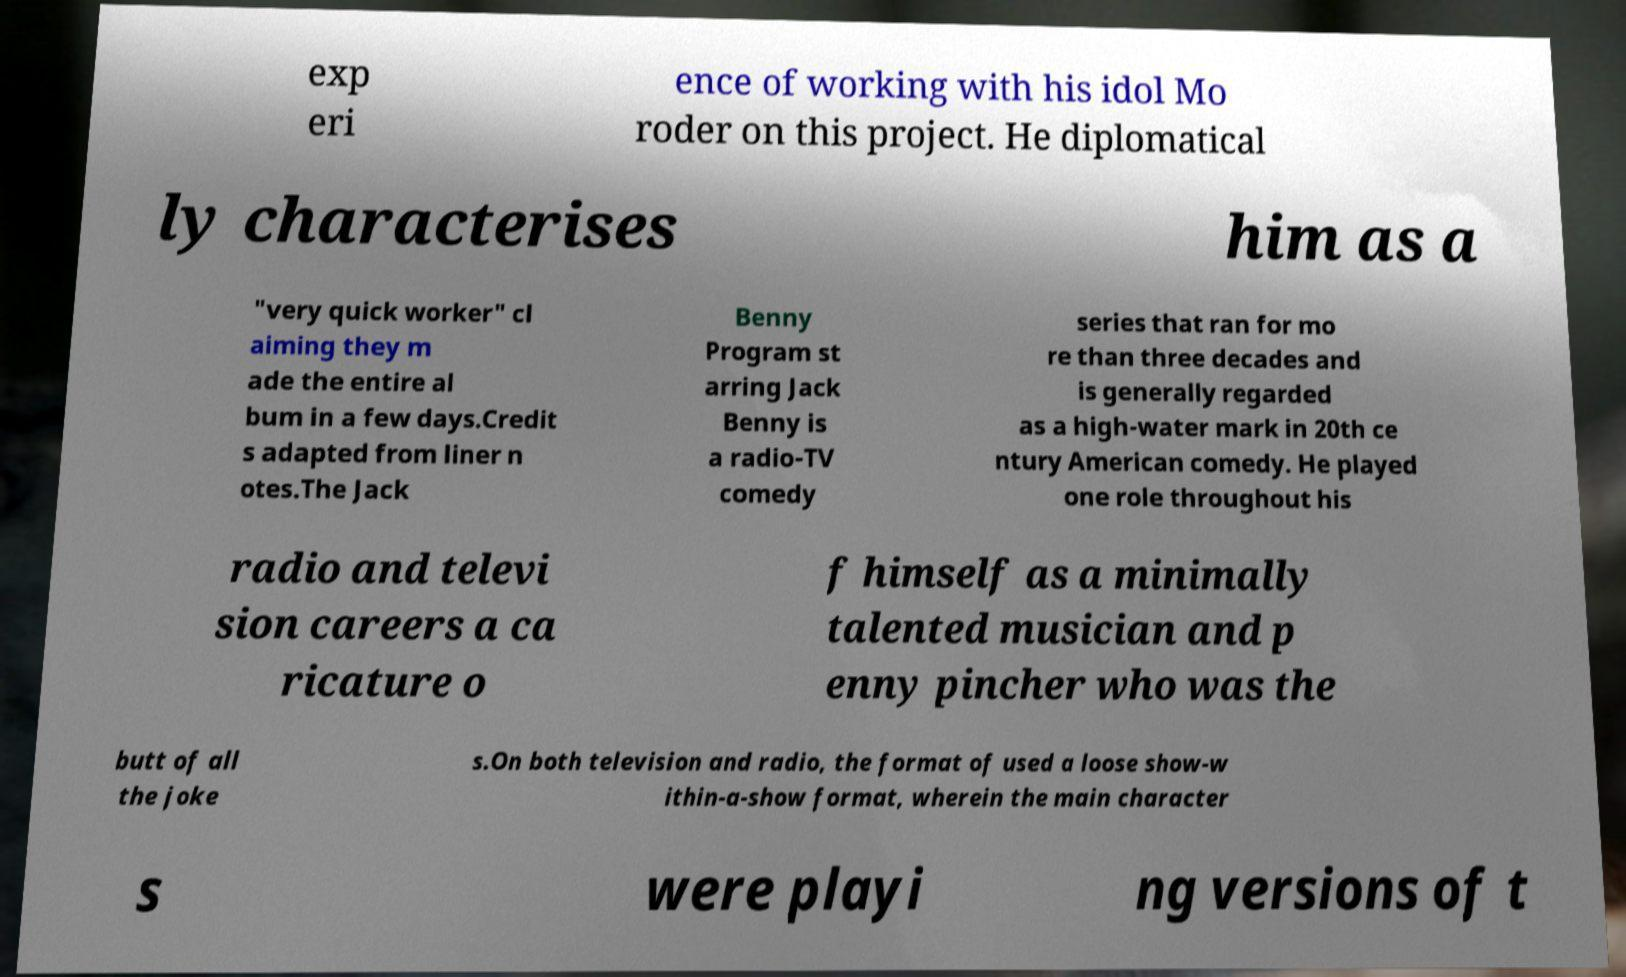Can you accurately transcribe the text from the provided image for me? exp eri ence of working with his idol Mo roder on this project. He diplomatical ly characterises him as a "very quick worker" cl aiming they m ade the entire al bum in a few days.Credit s adapted from liner n otes.The Jack Benny Program st arring Jack Benny is a radio-TV comedy series that ran for mo re than three decades and is generally regarded as a high-water mark in 20th ce ntury American comedy. He played one role throughout his radio and televi sion careers a ca ricature o f himself as a minimally talented musician and p enny pincher who was the butt of all the joke s.On both television and radio, the format of used a loose show-w ithin-a-show format, wherein the main character s were playi ng versions of t 